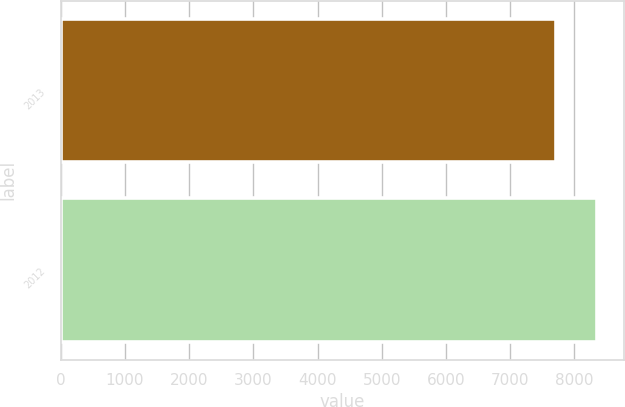Convert chart to OTSL. <chart><loc_0><loc_0><loc_500><loc_500><bar_chart><fcel>2013<fcel>2012<nl><fcel>7720<fcel>8355<nl></chart> 